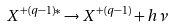<formula> <loc_0><loc_0><loc_500><loc_500>X ^ { + ( q - 1 ) * } \rightarrow X ^ { + ( q - 1 ) } + h \nu</formula> 